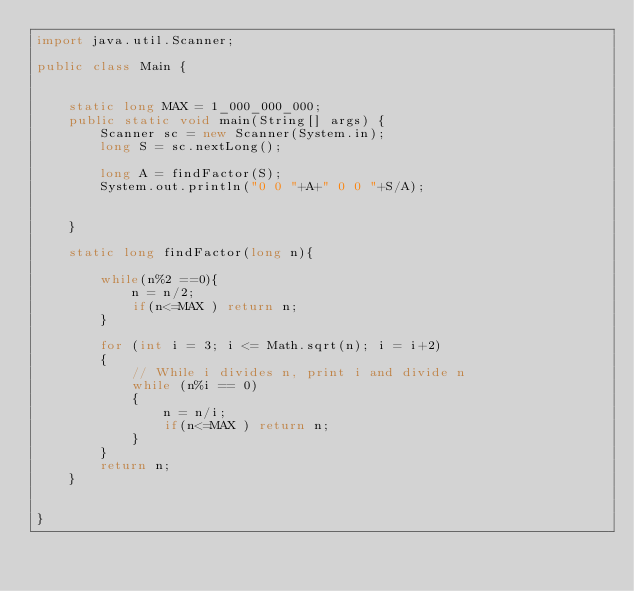Convert code to text. <code><loc_0><loc_0><loc_500><loc_500><_Java_>import java.util.Scanner;

public class Main {


    static long MAX = 1_000_000_000;
    public static void main(String[] args) {
        Scanner sc = new Scanner(System.in);
        long S = sc.nextLong();

        long A = findFactor(S);
        System.out.println("0 0 "+A+" 0 0 "+S/A);


    }

    static long findFactor(long n){

        while(n%2 ==0){
            n = n/2;
            if(n<=MAX ) return n;
        }

        for (int i = 3; i <= Math.sqrt(n); i = i+2)
        {
            // While i divides n, print i and divide n
            while (n%i == 0)
            {
                n = n/i;
                if(n<=MAX ) return n;
            }
        }
        return n;
    }


}
</code> 